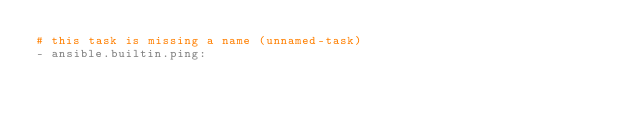Convert code to text. <code><loc_0><loc_0><loc_500><loc_500><_YAML_># this task is missing a name (unnamed-task)
- ansible.builtin.ping:
</code> 